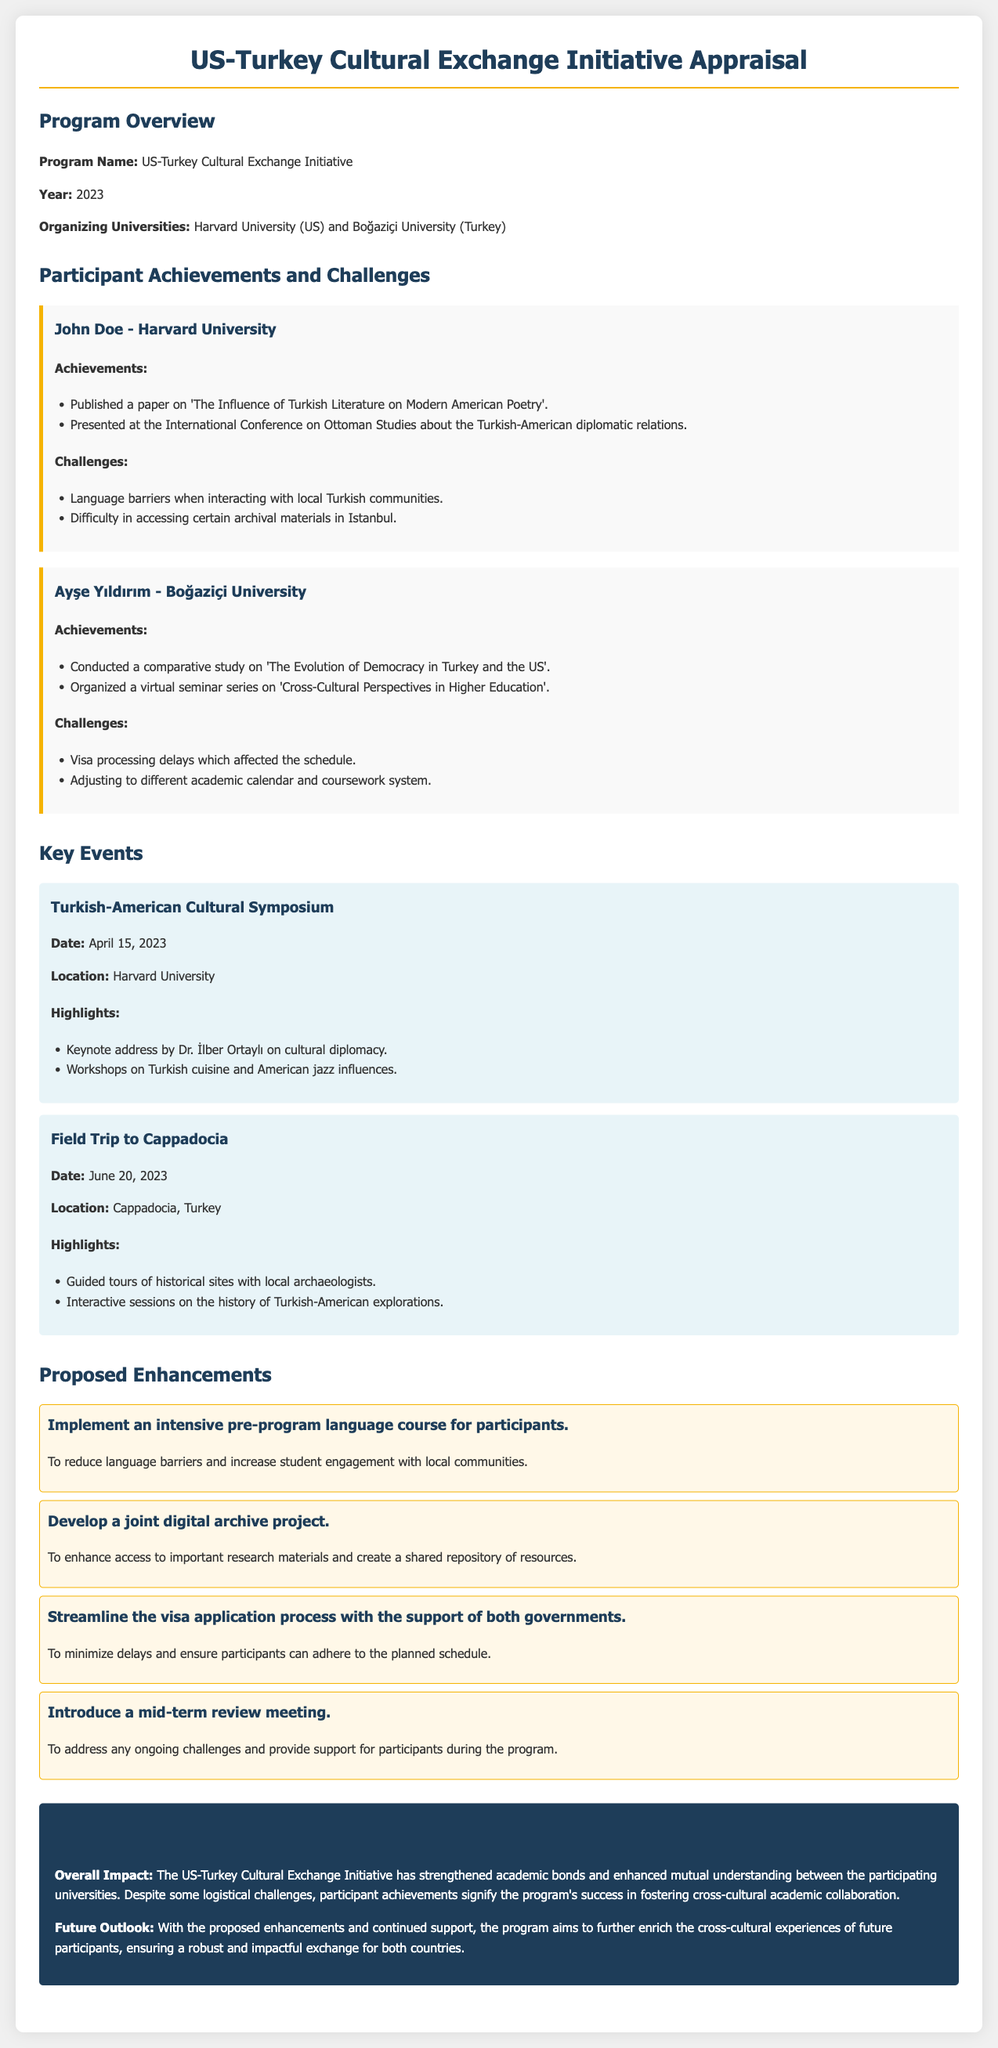What is the name of the program? The program is called the US-Turkey Cultural Exchange Initiative as stated in the program overview section.
Answer: US-Turkey Cultural Exchange Initiative Who organized the program? The organizing universities mentioned in the document are Harvard University and Boğaziçi University.
Answer: Harvard University and Boğaziçi University What was one of John Doe's achievements? John Doe's achievements include publishing a paper and presenting at a conference, both listed under his achievements section.
Answer: Published a paper on 'The Influence of Turkish Literature on Modern American Poetry' What date did the Turkish-American Cultural Symposium take place? The date is provided specifically under the key events section for that symposium.
Answer: April 15, 2023 What challenge did Ayşe Yıldırım face? The document lists specific challenges faced by Ayşe Yıldırım, one of which was visa processing delays.
Answer: Visa processing delays What is one proposed enhancement to the program? The proposed enhancements section lists several suggestions for improvement, asking for any enhancement will yield one of those.
Answer: Implement an intensive pre-program language course for participants How did the program impact relationships between the universities? The summary section reflects on the overall impact of the program on academic bonds and mutual understanding.
Answer: Strengthened academic bonds What event involved guided tours of historical sites? The event information is provided where this specific activity is highlighted, which reflects a cultural experience.
Answer: Field Trip to Cappadocia How many participants’ achievements and challenges are detailed in the document? The document explicitly mentions the two participants featured in the achievements and challenges section.
Answer: Two participants 